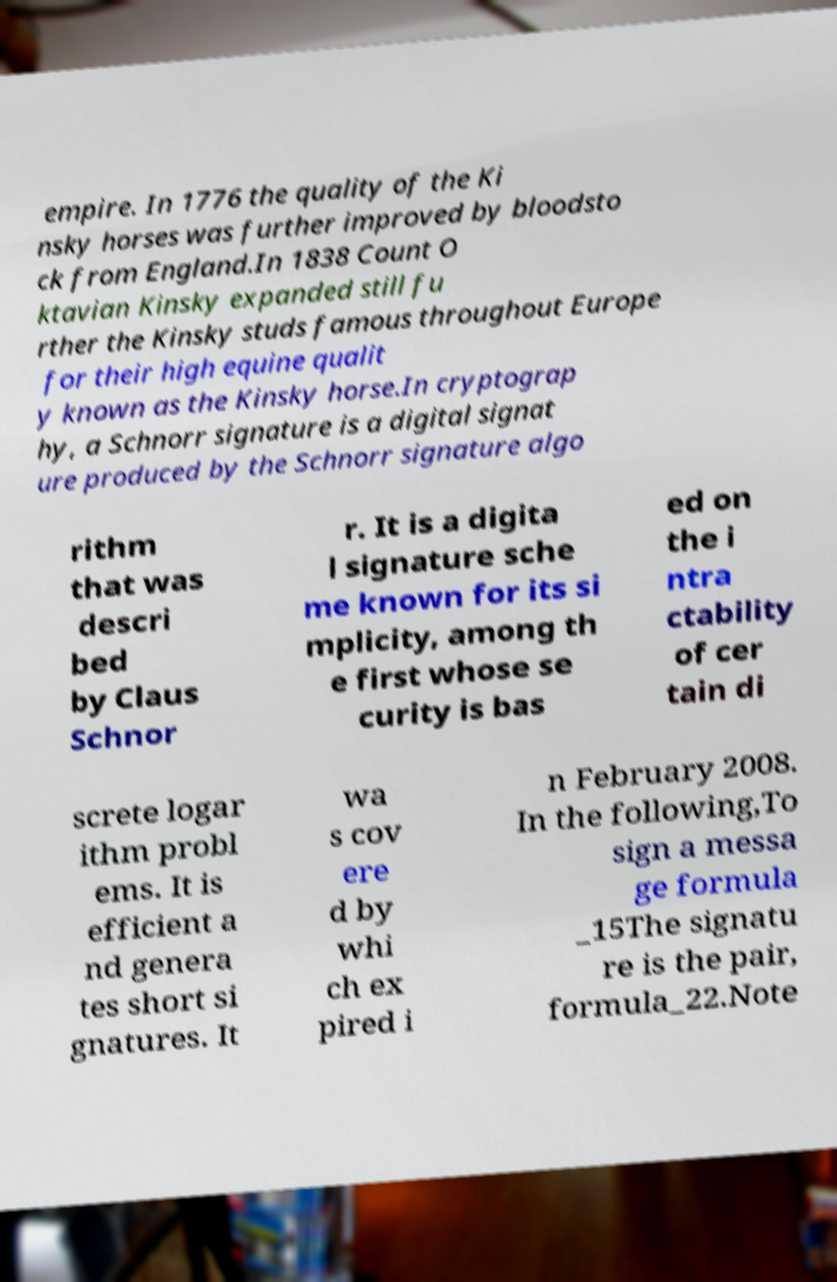Can you accurately transcribe the text from the provided image for me? empire. In 1776 the quality of the Ki nsky horses was further improved by bloodsto ck from England.In 1838 Count O ktavian Kinsky expanded still fu rther the Kinsky studs famous throughout Europe for their high equine qualit y known as the Kinsky horse.In cryptograp hy, a Schnorr signature is a digital signat ure produced by the Schnorr signature algo rithm that was descri bed by Claus Schnor r. It is a digita l signature sche me known for its si mplicity, among th e first whose se curity is bas ed on the i ntra ctability of cer tain di screte logar ithm probl ems. It is efficient a nd genera tes short si gnatures. It wa s cov ere d by whi ch ex pired i n February 2008. In the following,To sign a messa ge formula _15The signatu re is the pair, formula_22.Note 